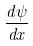<formula> <loc_0><loc_0><loc_500><loc_500>\frac { d \psi } { d x }</formula> 